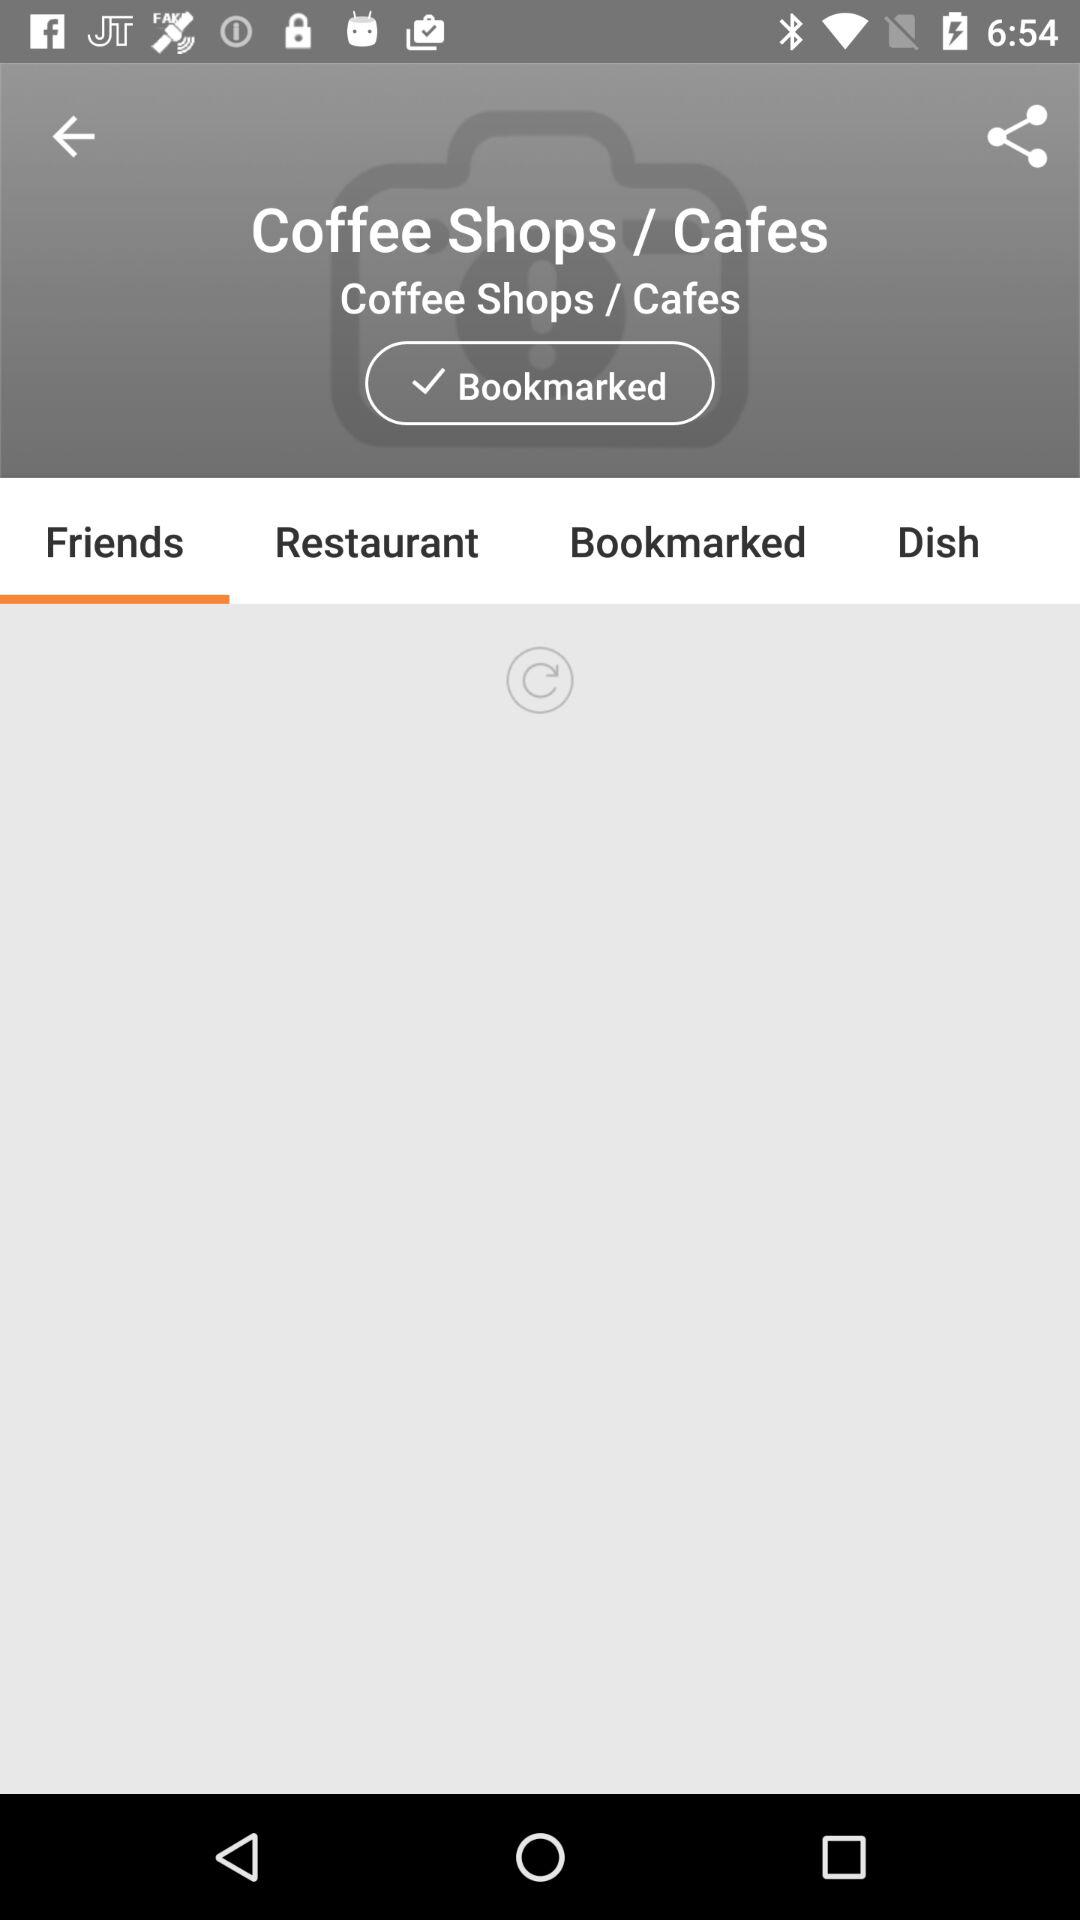Which tab is currently selected? The currently selected tab is "Friends". 